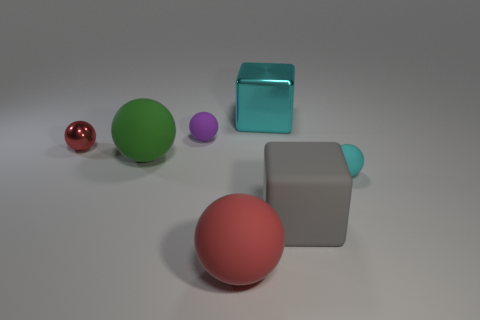What size is the gray matte cube?
Offer a very short reply. Large. Is there another rubber thing that has the same shape as the tiny red object?
Provide a short and direct response. Yes. Do the large cyan object and the big gray rubber thing on the right side of the cyan metallic object have the same shape?
Ensure brevity in your answer.  Yes. How big is the ball that is both behind the large green matte ball and on the right side of the red metal thing?
Give a very brief answer. Small. What number of red shiny cubes are there?
Keep it short and to the point. 0. There is a cyan sphere that is the same size as the purple object; what material is it?
Offer a terse response. Rubber. Is there a red object that has the same size as the cyan rubber object?
Offer a terse response. Yes. Is the color of the small rubber sphere behind the large green rubber sphere the same as the small rubber ball that is to the right of the big gray block?
Your answer should be compact. No. What number of matte things are either cyan blocks or small blue cylinders?
Offer a terse response. 0. What number of blocks are behind the rubber ball behind the red ball behind the large green sphere?
Offer a very short reply. 1. 